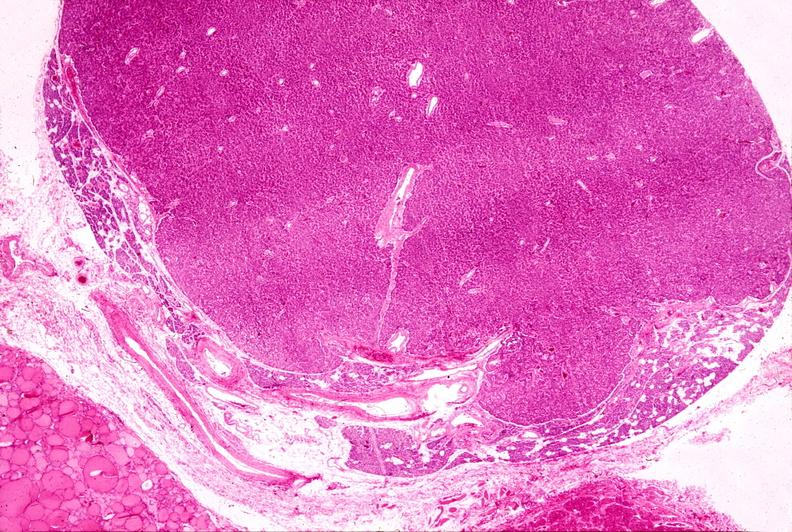does cm show parathyroid adenoma, h & e low mag?
Answer the question using a single word or phrase. No 